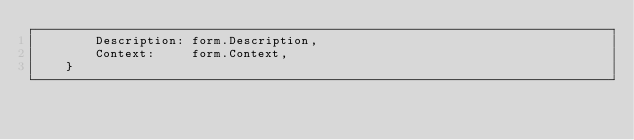<code> <loc_0><loc_0><loc_500><loc_500><_Go_>		Description: form.Description,
		Context:     form.Context,
	}</code> 